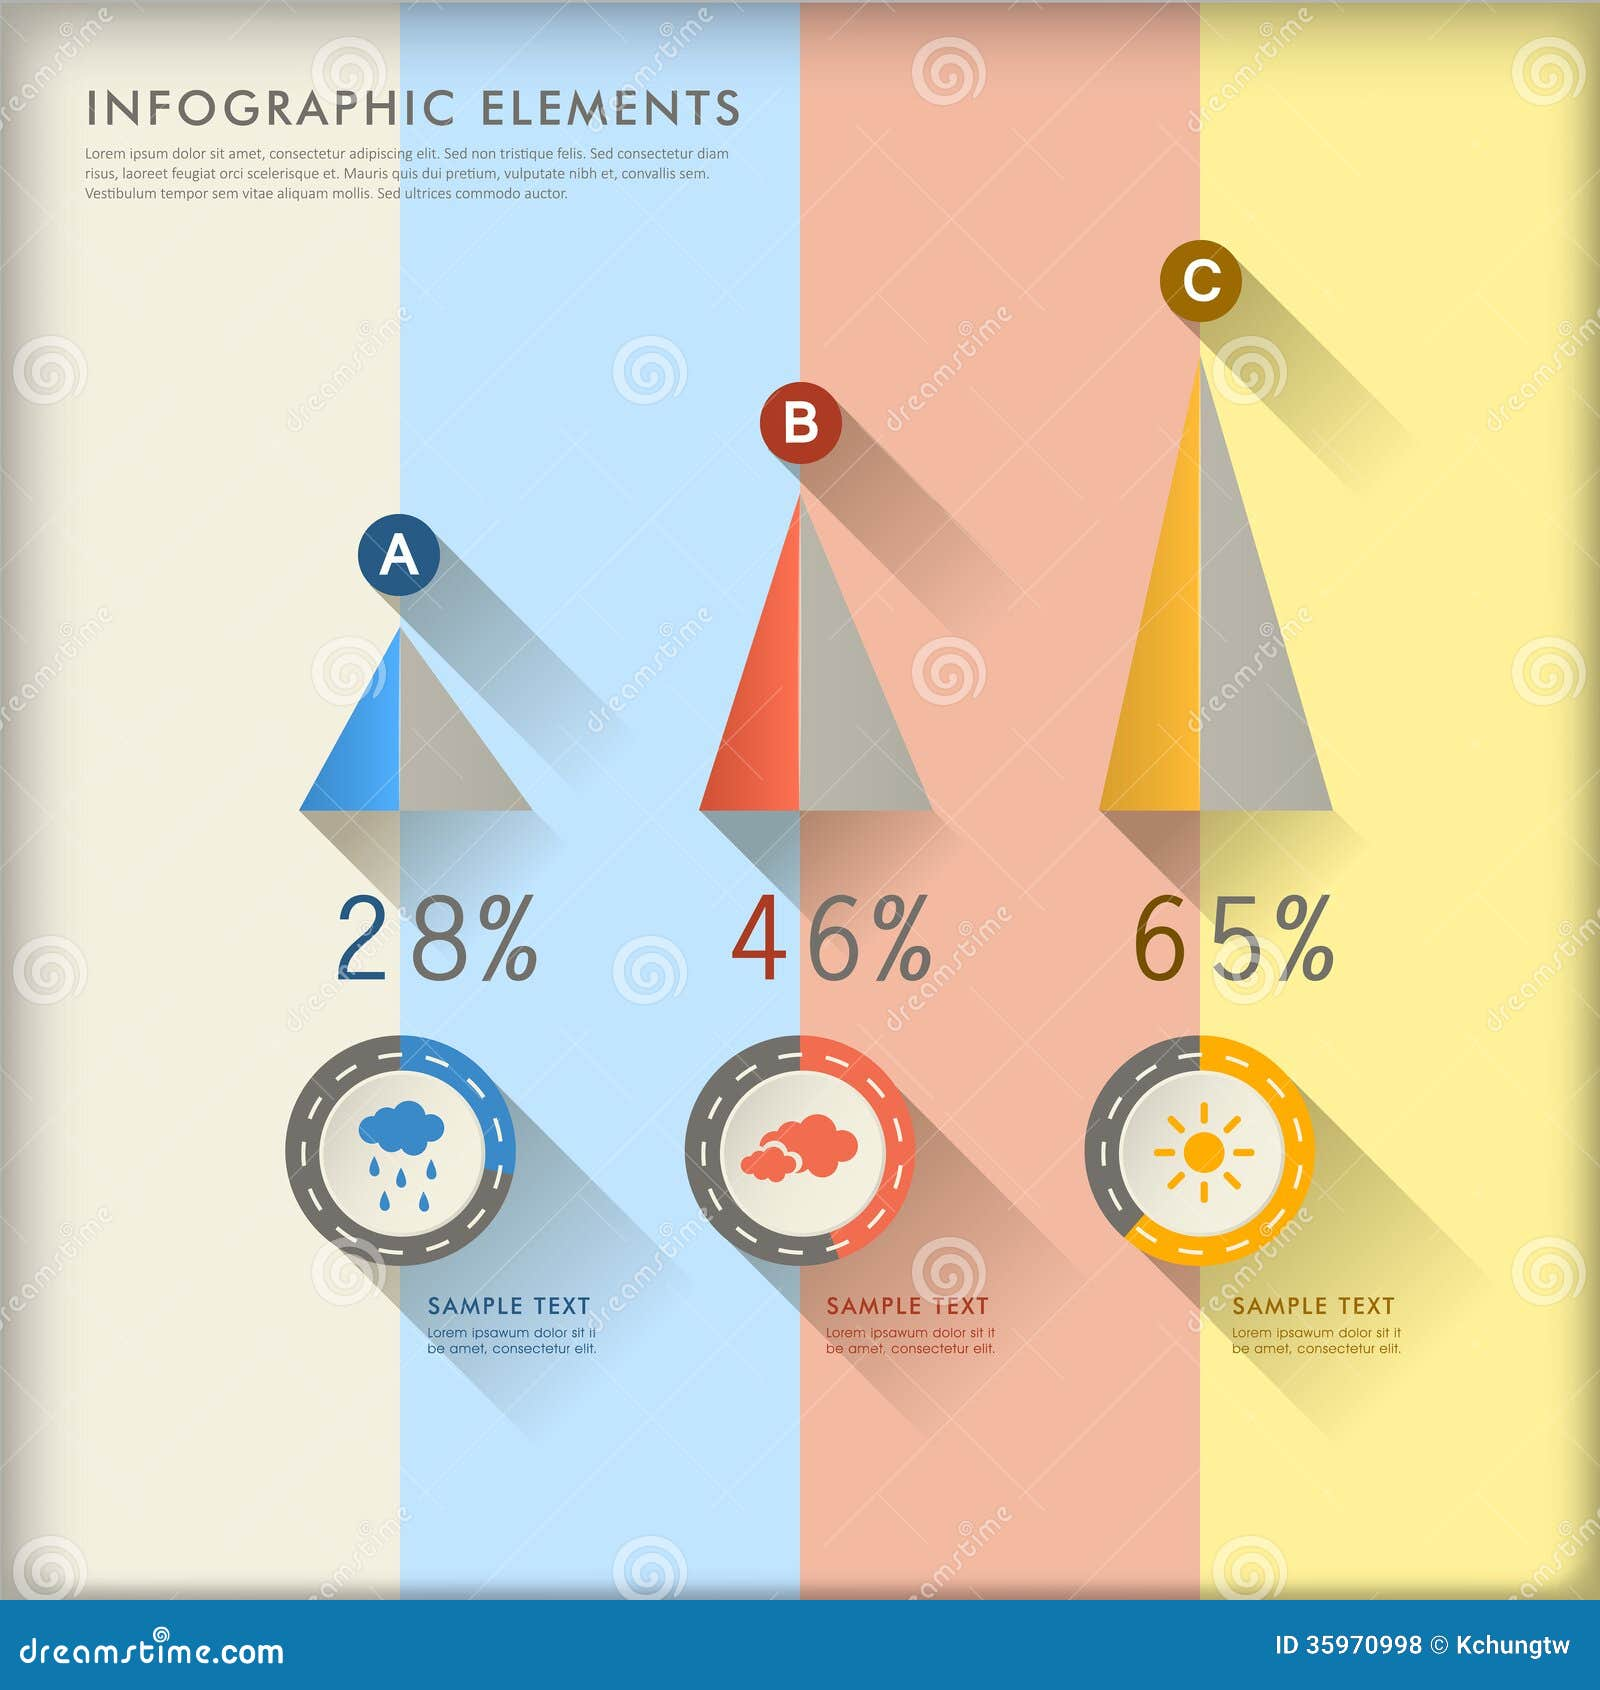Create a detailed backstory for a fictional world where this infographic captures the weather patterns affecting the lives of the inhabitants. In the enchanted world of Zephyria, weather patterns play a crucial role in the daily lives and well-being of its inhabitants. The infographic is a snapshot of the magical climate data gathered over centuries by the Weather Mages of Zephyria. Category A, depicted by the rain cloud at 28%, represents the Tearfall Season, where the skies weep in harmony with the Guardian Spirits of the Silver Lakes, bringing necessary rain for the fertile lands. Category B, marked by the red cloud at 46%, symbolizes the Mists of Murmura, a mysterious phenomenon where the crimson fog from the Brimstone Peaks descends upon the valleys, affecting visibility and necessitating the use of enchanted lanterns. Category C, with the sun icon and 65%, signifies the Glory Days, when the Sunfire Orb illuminates the realm, boosting crop growth and elevating the magic of all creatures. Each weather pattern profoundly impacts not just the environment but also the culture, daily routines, and magical practices within Zephyria, making this infographic an essential guide for its denizens. 